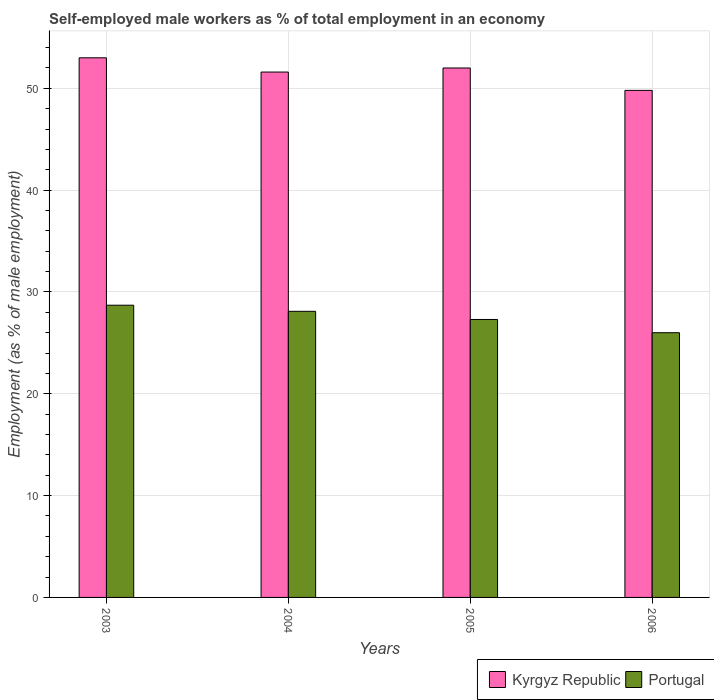How many different coloured bars are there?
Your answer should be compact. 2. How many groups of bars are there?
Provide a succinct answer. 4. Are the number of bars per tick equal to the number of legend labels?
Provide a succinct answer. Yes. Are the number of bars on each tick of the X-axis equal?
Your response must be concise. Yes. How many bars are there on the 4th tick from the left?
Offer a terse response. 2. What is the label of the 1st group of bars from the left?
Provide a succinct answer. 2003. What is the percentage of self-employed male workers in Portugal in 2003?
Offer a very short reply. 28.7. Across all years, what is the maximum percentage of self-employed male workers in Kyrgyz Republic?
Your response must be concise. 53. Across all years, what is the minimum percentage of self-employed male workers in Portugal?
Your response must be concise. 26. In which year was the percentage of self-employed male workers in Kyrgyz Republic minimum?
Keep it short and to the point. 2006. What is the total percentage of self-employed male workers in Portugal in the graph?
Keep it short and to the point. 110.1. What is the difference between the percentage of self-employed male workers in Portugal in 2003 and that in 2005?
Ensure brevity in your answer.  1.4. What is the difference between the percentage of self-employed male workers in Kyrgyz Republic in 2003 and the percentage of self-employed male workers in Portugal in 2005?
Your response must be concise. 25.7. What is the average percentage of self-employed male workers in Portugal per year?
Your answer should be compact. 27.53. In the year 2006, what is the difference between the percentage of self-employed male workers in Portugal and percentage of self-employed male workers in Kyrgyz Republic?
Offer a very short reply. -23.8. In how many years, is the percentage of self-employed male workers in Portugal greater than 50 %?
Offer a very short reply. 0. What is the ratio of the percentage of self-employed male workers in Portugal in 2005 to that in 2006?
Give a very brief answer. 1.05. Is the percentage of self-employed male workers in Kyrgyz Republic in 2004 less than that in 2005?
Provide a succinct answer. Yes. Is the difference between the percentage of self-employed male workers in Portugal in 2003 and 2006 greater than the difference between the percentage of self-employed male workers in Kyrgyz Republic in 2003 and 2006?
Offer a very short reply. No. What is the difference between the highest and the lowest percentage of self-employed male workers in Portugal?
Offer a very short reply. 2.7. Is the sum of the percentage of self-employed male workers in Portugal in 2005 and 2006 greater than the maximum percentage of self-employed male workers in Kyrgyz Republic across all years?
Offer a very short reply. Yes. What does the 1st bar from the left in 2003 represents?
Your answer should be very brief. Kyrgyz Republic. What does the 2nd bar from the right in 2006 represents?
Make the answer very short. Kyrgyz Republic. How many bars are there?
Keep it short and to the point. 8. Are all the bars in the graph horizontal?
Offer a terse response. No. How many years are there in the graph?
Give a very brief answer. 4. What is the difference between two consecutive major ticks on the Y-axis?
Ensure brevity in your answer.  10. Are the values on the major ticks of Y-axis written in scientific E-notation?
Ensure brevity in your answer.  No. Where does the legend appear in the graph?
Ensure brevity in your answer.  Bottom right. How are the legend labels stacked?
Keep it short and to the point. Horizontal. What is the title of the graph?
Provide a short and direct response. Self-employed male workers as % of total employment in an economy. Does "French Polynesia" appear as one of the legend labels in the graph?
Provide a short and direct response. No. What is the label or title of the Y-axis?
Keep it short and to the point. Employment (as % of male employment). What is the Employment (as % of male employment) in Kyrgyz Republic in 2003?
Your answer should be compact. 53. What is the Employment (as % of male employment) of Portugal in 2003?
Your answer should be very brief. 28.7. What is the Employment (as % of male employment) in Kyrgyz Republic in 2004?
Offer a terse response. 51.6. What is the Employment (as % of male employment) in Portugal in 2004?
Keep it short and to the point. 28.1. What is the Employment (as % of male employment) in Portugal in 2005?
Keep it short and to the point. 27.3. What is the Employment (as % of male employment) in Kyrgyz Republic in 2006?
Your response must be concise. 49.8. What is the Employment (as % of male employment) in Portugal in 2006?
Make the answer very short. 26. Across all years, what is the maximum Employment (as % of male employment) of Portugal?
Ensure brevity in your answer.  28.7. Across all years, what is the minimum Employment (as % of male employment) of Kyrgyz Republic?
Ensure brevity in your answer.  49.8. Across all years, what is the minimum Employment (as % of male employment) in Portugal?
Your answer should be compact. 26. What is the total Employment (as % of male employment) of Kyrgyz Republic in the graph?
Provide a succinct answer. 206.4. What is the total Employment (as % of male employment) in Portugal in the graph?
Your response must be concise. 110.1. What is the difference between the Employment (as % of male employment) in Portugal in 2003 and that in 2004?
Provide a succinct answer. 0.6. What is the difference between the Employment (as % of male employment) of Kyrgyz Republic in 2003 and that in 2005?
Give a very brief answer. 1. What is the difference between the Employment (as % of male employment) of Portugal in 2003 and that in 2005?
Give a very brief answer. 1.4. What is the difference between the Employment (as % of male employment) of Kyrgyz Republic in 2003 and that in 2006?
Offer a very short reply. 3.2. What is the difference between the Employment (as % of male employment) in Portugal in 2003 and that in 2006?
Offer a very short reply. 2.7. What is the difference between the Employment (as % of male employment) in Kyrgyz Republic in 2004 and that in 2005?
Offer a very short reply. -0.4. What is the difference between the Employment (as % of male employment) in Kyrgyz Republic in 2004 and that in 2006?
Your answer should be very brief. 1.8. What is the difference between the Employment (as % of male employment) in Portugal in 2004 and that in 2006?
Provide a succinct answer. 2.1. What is the difference between the Employment (as % of male employment) in Portugal in 2005 and that in 2006?
Offer a very short reply. 1.3. What is the difference between the Employment (as % of male employment) of Kyrgyz Republic in 2003 and the Employment (as % of male employment) of Portugal in 2004?
Offer a terse response. 24.9. What is the difference between the Employment (as % of male employment) in Kyrgyz Republic in 2003 and the Employment (as % of male employment) in Portugal in 2005?
Provide a succinct answer. 25.7. What is the difference between the Employment (as % of male employment) in Kyrgyz Republic in 2004 and the Employment (as % of male employment) in Portugal in 2005?
Provide a succinct answer. 24.3. What is the difference between the Employment (as % of male employment) in Kyrgyz Republic in 2004 and the Employment (as % of male employment) in Portugal in 2006?
Ensure brevity in your answer.  25.6. What is the difference between the Employment (as % of male employment) in Kyrgyz Republic in 2005 and the Employment (as % of male employment) in Portugal in 2006?
Offer a terse response. 26. What is the average Employment (as % of male employment) of Kyrgyz Republic per year?
Give a very brief answer. 51.6. What is the average Employment (as % of male employment) in Portugal per year?
Your answer should be very brief. 27.52. In the year 2003, what is the difference between the Employment (as % of male employment) in Kyrgyz Republic and Employment (as % of male employment) in Portugal?
Your answer should be compact. 24.3. In the year 2004, what is the difference between the Employment (as % of male employment) of Kyrgyz Republic and Employment (as % of male employment) of Portugal?
Provide a short and direct response. 23.5. In the year 2005, what is the difference between the Employment (as % of male employment) in Kyrgyz Republic and Employment (as % of male employment) in Portugal?
Provide a short and direct response. 24.7. In the year 2006, what is the difference between the Employment (as % of male employment) in Kyrgyz Republic and Employment (as % of male employment) in Portugal?
Give a very brief answer. 23.8. What is the ratio of the Employment (as % of male employment) of Kyrgyz Republic in 2003 to that in 2004?
Offer a terse response. 1.03. What is the ratio of the Employment (as % of male employment) in Portugal in 2003 to that in 2004?
Keep it short and to the point. 1.02. What is the ratio of the Employment (as % of male employment) in Kyrgyz Republic in 2003 to that in 2005?
Make the answer very short. 1.02. What is the ratio of the Employment (as % of male employment) of Portugal in 2003 to that in 2005?
Ensure brevity in your answer.  1.05. What is the ratio of the Employment (as % of male employment) of Kyrgyz Republic in 2003 to that in 2006?
Your answer should be very brief. 1.06. What is the ratio of the Employment (as % of male employment) of Portugal in 2003 to that in 2006?
Provide a short and direct response. 1.1. What is the ratio of the Employment (as % of male employment) in Portugal in 2004 to that in 2005?
Ensure brevity in your answer.  1.03. What is the ratio of the Employment (as % of male employment) in Kyrgyz Republic in 2004 to that in 2006?
Your answer should be compact. 1.04. What is the ratio of the Employment (as % of male employment) of Portugal in 2004 to that in 2006?
Your answer should be compact. 1.08. What is the ratio of the Employment (as % of male employment) of Kyrgyz Republic in 2005 to that in 2006?
Offer a terse response. 1.04. What is the ratio of the Employment (as % of male employment) in Portugal in 2005 to that in 2006?
Provide a succinct answer. 1.05. What is the difference between the highest and the second highest Employment (as % of male employment) in Kyrgyz Republic?
Provide a succinct answer. 1. What is the difference between the highest and the lowest Employment (as % of male employment) of Kyrgyz Republic?
Ensure brevity in your answer.  3.2. 